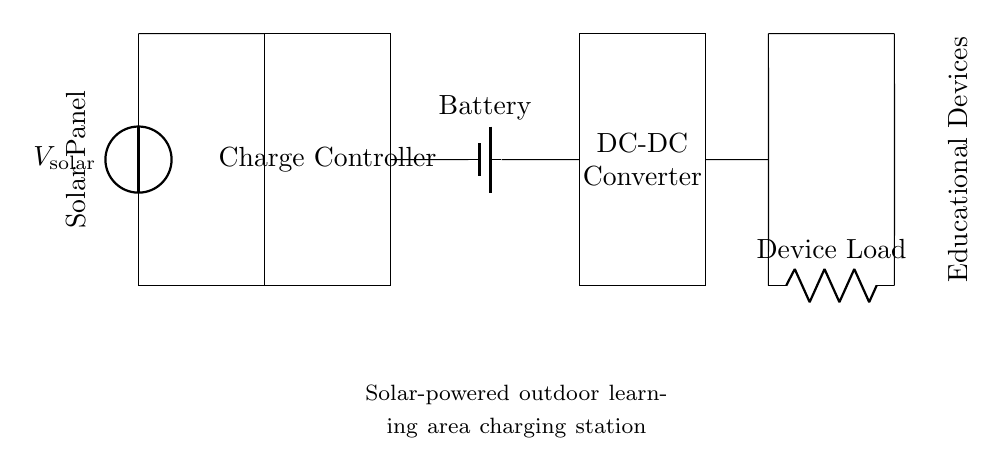What is the function of the charge controller? The charge controller regulates the charging process from the solar panel to the battery, ensuring that the battery is charged properly and preventing overcharging.
Answer: Regulates charging What component converts the voltage from the battery to power educational devices? The DC-DC converter is responsible for adjusting the voltage output from the battery to the appropriate level required for the educational devices.
Answer: DC-DC converter What do the educational devices connect to? The educational devices connect to the output terminals of the circuit, indicated by the connections from the DC-DC converter to the device load.
Answer: Output terminals How many main components are in this circuit? There are four main components: the solar panel, charge controller, battery, and DC-DC converter, which work together in the circuit.
Answer: Four Which component is responsible for energy storage? The battery stores energy generated by the solar panel for later use in powering educational devices.
Answer: Battery How does the solar panel impact the charging process? The solar panel generates electricity from sunlight, supplying the charge controller, which in turn controls the flow of energy into the battery.
Answer: Generates electricity 